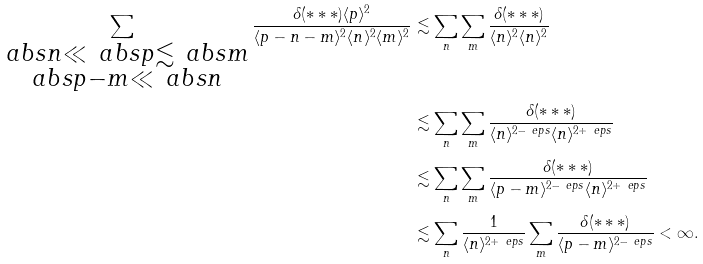<formula> <loc_0><loc_0><loc_500><loc_500>\sum _ { \substack { \ a b s { n } \ll \ a b s { p } \lesssim \ a b s { m } \\ \ a b s { p - m } \ll \ a b s { n } } } \frac { \delta ( * * * ) \langle p \rangle ^ { 2 } } { \langle { p - n - m } \rangle ^ { 2 } \langle n \rangle ^ { 2 } \langle m \rangle ^ { 2 } } & \lesssim \sum _ { n } \sum _ { m } \frac { \delta ( * * * ) } { \langle { n } \rangle ^ { 2 } \langle n \rangle ^ { 2 } } \\ & \lesssim \sum _ { n } \sum _ { m } \frac { \delta ( * * * ) } { \langle { n } \rangle ^ { 2 - \ e p s } \langle n \rangle ^ { 2 + \ e p s } } \\ & \lesssim \sum _ { n } \sum _ { m } \frac { \delta ( * * * ) } { \langle { p - m } \rangle ^ { 2 - \ e p s } \langle n \rangle ^ { 2 + \ e p s } } \\ & \lesssim \sum _ { n } \frac { 1 } { \langle n \rangle ^ { 2 + \ e p s } } \sum _ { m } \frac { \delta ( * * * ) } { \langle p - m \rangle ^ { 2 - \ e p s } } < \infty .</formula> 